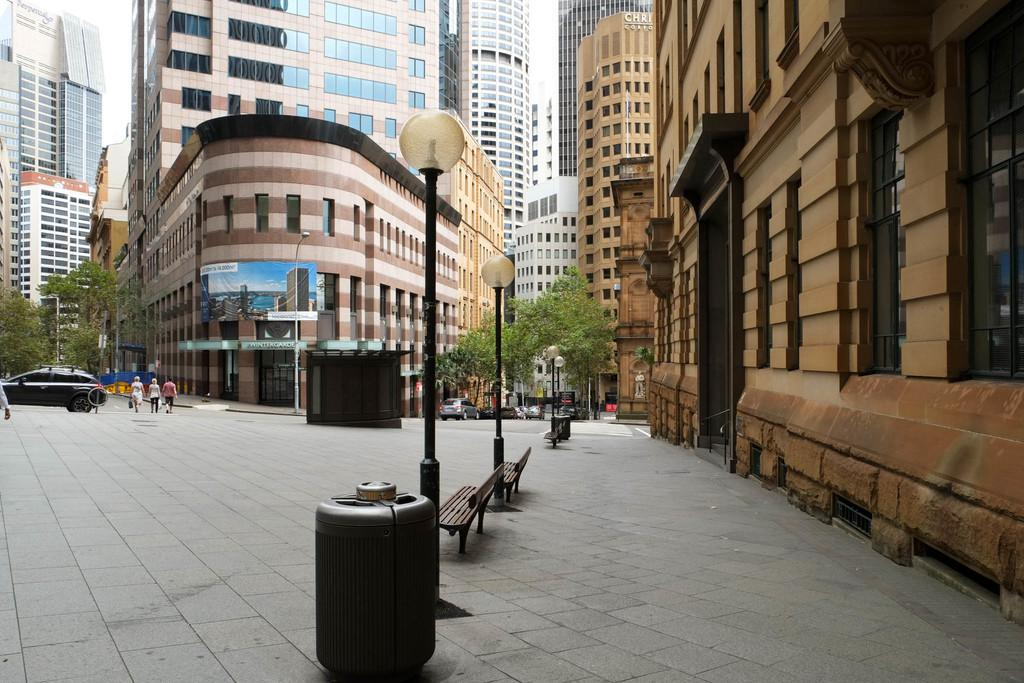What type of seating is visible in the image? There are benches in the image. What structures provide illumination in the image? There are light poles in the image. What types of transportation are present in the image? There are vehicles in the image. What can be seen on the ground in the image? There are people on the ground in the image. What is hanging in the background of the image? There is a banner in the background of the image. What type of natural elements are visible in the background of the image? There are trees in the background of the image. What type of structures are visible in the background of the image? There are buildings with windows in the background of the image. What type of sugar is being used to attract the people in the image? There is no sugar present in the image, and therefore no such attraction can be observed. What type of connection is being made between the people in the image? The image does not show any specific connections between the people; they are simply standing or walking on the ground. 